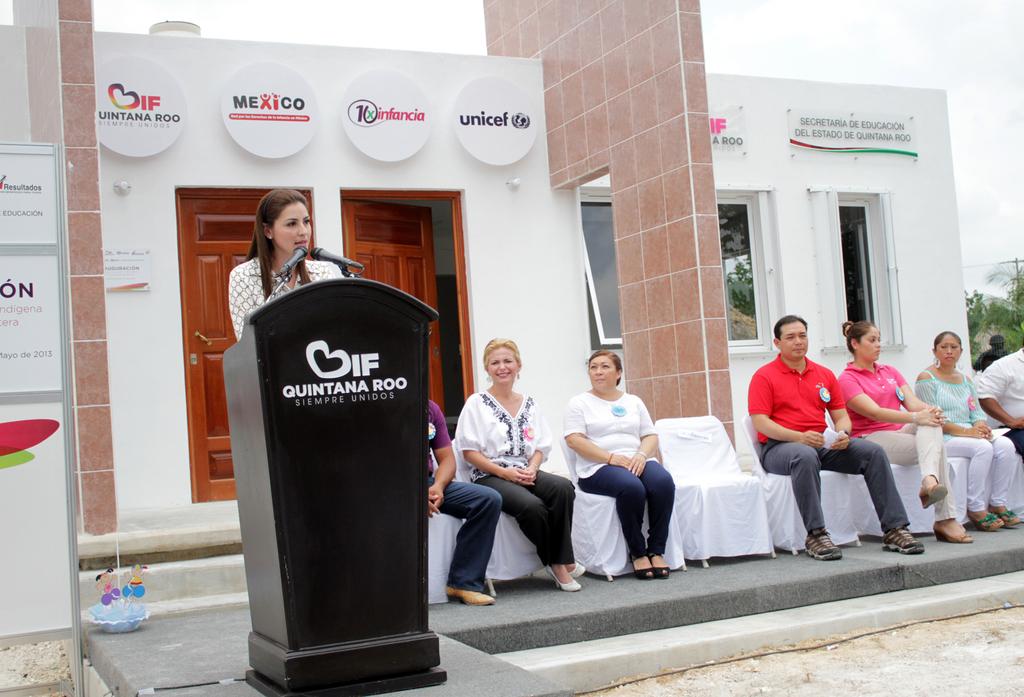Which company logo is at the top right?
Offer a terse response. Unicel. What does it say on the podium?
Your answer should be compact. Quintana roo siempre unidos. 